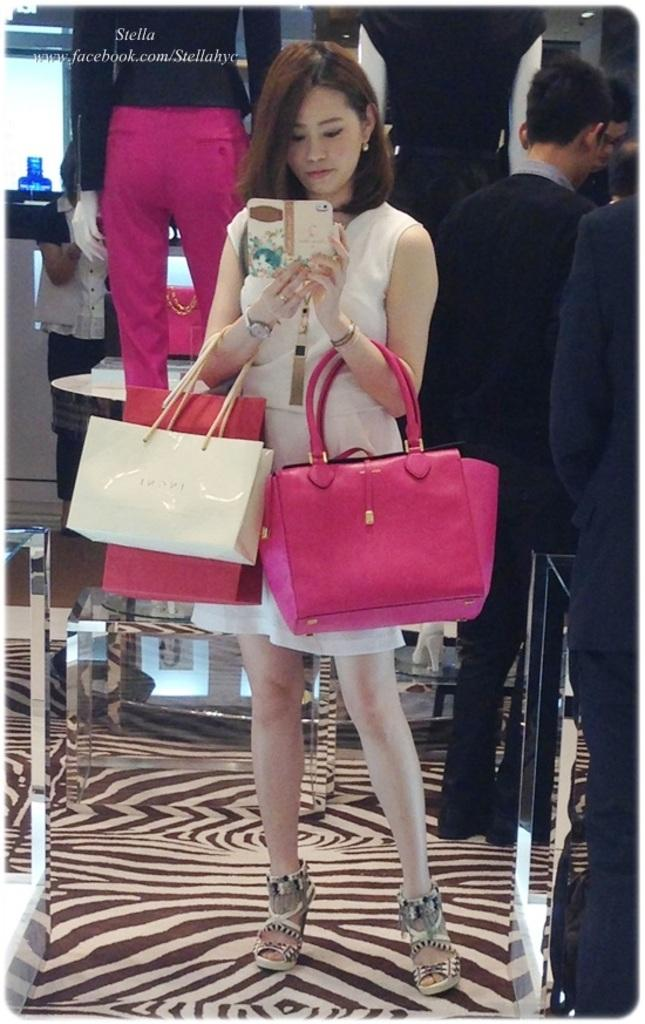What are the people in the image doing? The people in the image are standing. What object is the woman holding in her hand? The woman is holding a mobile phone. What accessory is the woman holding in her other hand? The woman is holding a handbag. What type of treatment is the crow receiving from the people in the image? There is no crow present in the image, so no treatment can be observed. 